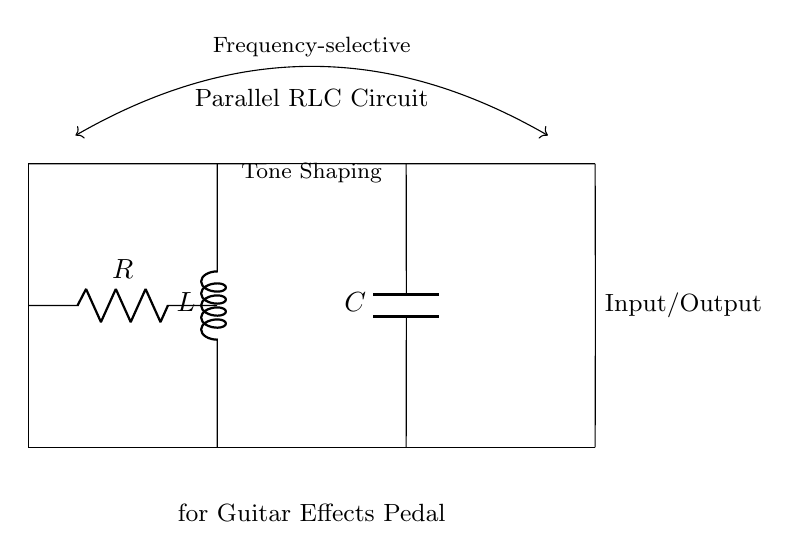What components are in this circuit? The circuit contains a resistor, an inductor, and a capacitor, which are common elements in parallel RLC circuits. These components are labeled as R, L, and C, respectively, in the diagram.
Answer: Resistor, Inductor, Capacitor What configuration is this circuit using? The circuit is configured in parallel, as indicated by the arrangement of the components where each one connects to the same two nodes. This configuration allows the components to share the same voltage across them while the current can vary separately through each component.
Answer: Parallel What is the primary function of this circuit? The primary function of this circuit is frequency-selective tone shaping, as noted in the annotations on the diagram which highlight its application for guitar effects pedals. This means it can filter specific frequencies to shape the tone of the guitar signal.
Answer: Frequency-selective tone shaping Which component is responsible for filtering high frequencies? The capacitor is responsible for filtering high frequencies in a parallel RLC circuit. Capacitors block low frequencies and allow high frequencies to pass, which affects the overall tone shaping for the guitar signal.
Answer: Capacitor How does the inductor affect the circuit's performance? The inductor affects the circuit's performance by providing impedance to alternating current, particularly at high frequencies. It stores energy in a magnetic field and opposes changes in current, which can help filter certain frequencies and contributes to the tonal characteristics of the circuit.
Answer: Impedance What happens when the resistance value is increased? When the resistance value is increased, the overall current flowing through the circuit will decrease for a constant voltage due to Ohm’s law (current equals voltage divided by resistance). This change in current affects the tone shaping capabilities of the circuit since the interaction between the resistor, inductor, and capacitor is altered.
Answer: Decreased current 